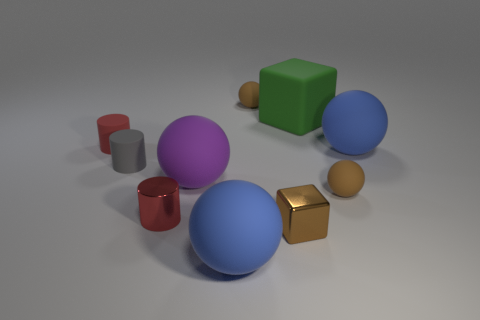What is the shape of the small gray thing that is the same material as the purple sphere?
Offer a very short reply. Cylinder. Is the size of the red rubber thing the same as the green object?
Give a very brief answer. No. There is a rubber sphere that is in front of the brown thing that is to the right of the brown cube; what is its size?
Offer a terse response. Large. There is a object that is the same color as the tiny shiny cylinder; what shape is it?
Ensure brevity in your answer.  Cylinder. How many spheres are either gray objects or tiny brown shiny things?
Keep it short and to the point. 0. Does the gray cylinder have the same size as the shiny thing that is to the left of the purple matte object?
Your response must be concise. Yes. Is the number of small brown metal blocks left of the brown block greater than the number of tiny gray cylinders?
Provide a short and direct response. No. There is a purple thing that is the same material as the green thing; what is its size?
Offer a terse response. Large. Is there a cylinder that has the same color as the small block?
Keep it short and to the point. No. What number of objects are either small metallic blocks or small brown rubber balls that are behind the purple rubber object?
Your answer should be compact. 2. 